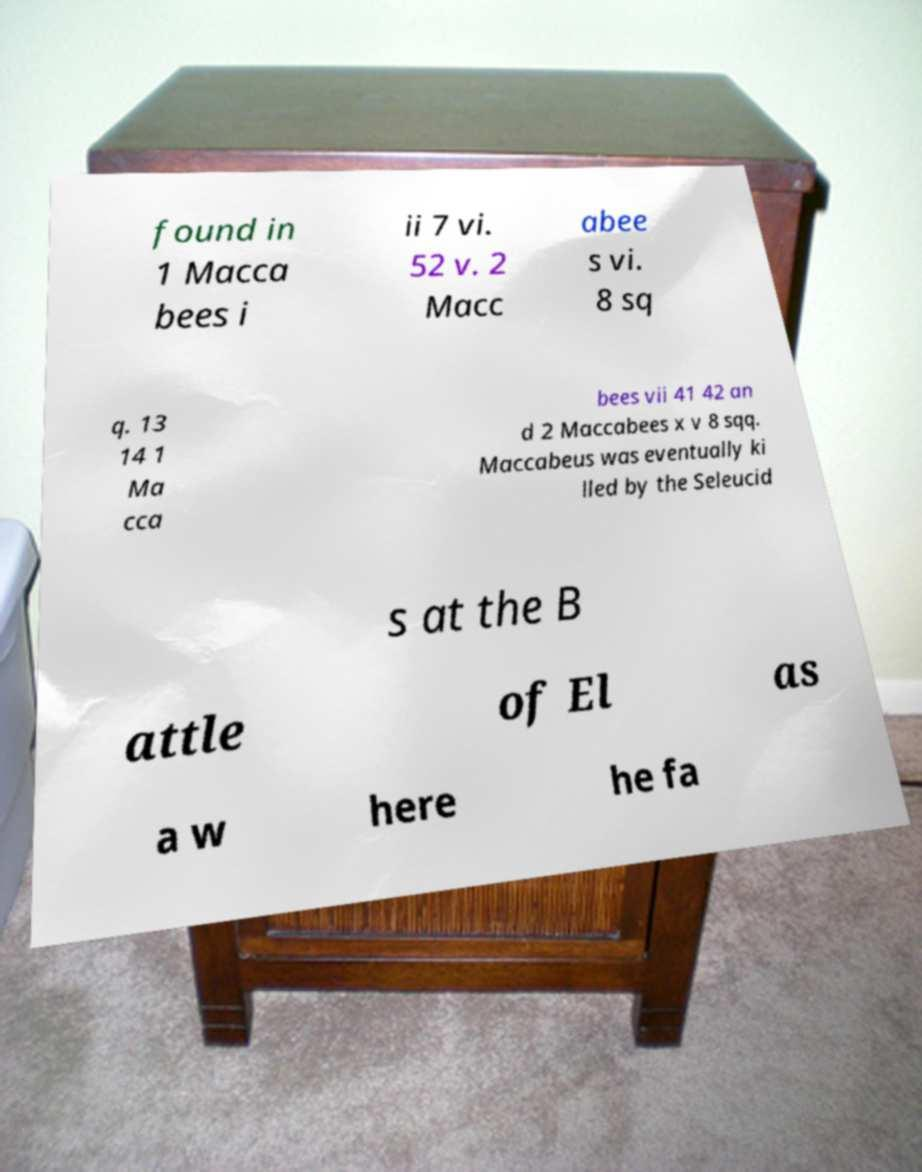What messages or text are displayed in this image? I need them in a readable, typed format. found in 1 Macca bees i ii 7 vi. 52 v. 2 Macc abee s vi. 8 sq q. 13 14 1 Ma cca bees vii 41 42 an d 2 Maccabees x v 8 sqq. Maccabeus was eventually ki lled by the Seleucid s at the B attle of El as a w here he fa 